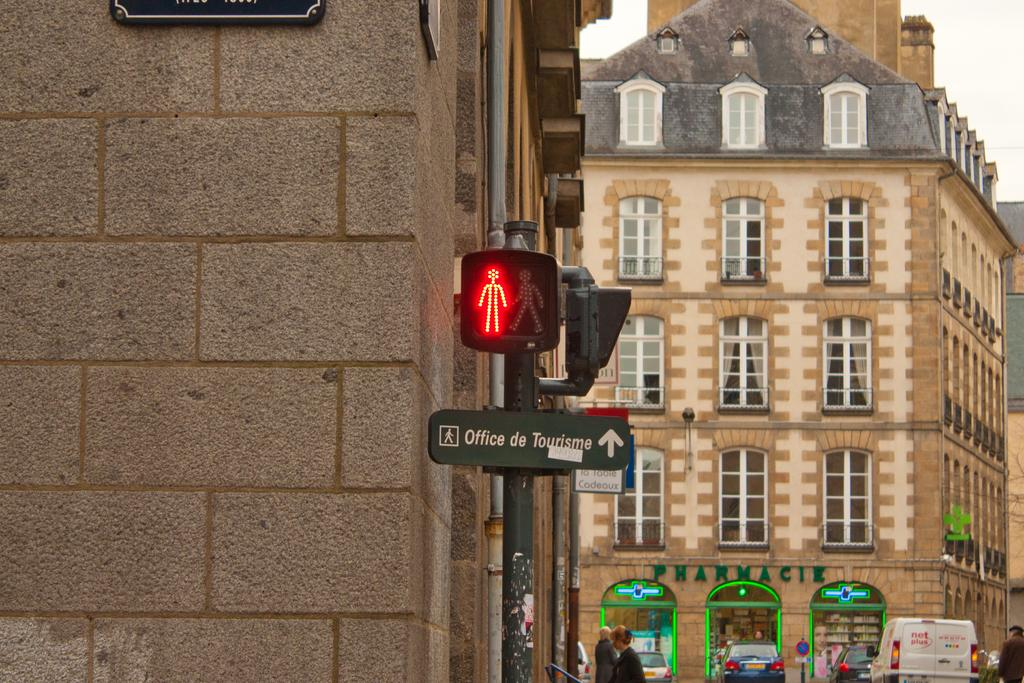<image>
Describe the image concisely. A street sign on a post indicates that the Office de Tourisme is straight ahead. 